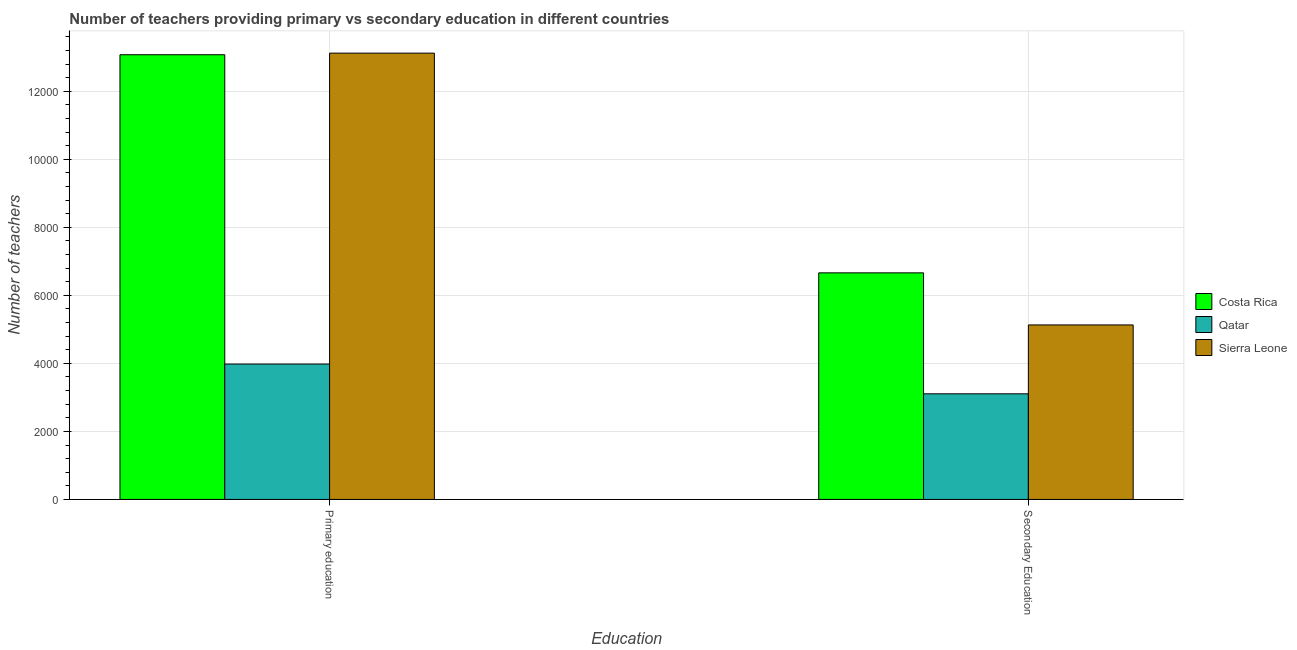How many groups of bars are there?
Offer a very short reply. 2. Are the number of bars per tick equal to the number of legend labels?
Your answer should be compact. Yes. Are the number of bars on each tick of the X-axis equal?
Your answer should be very brief. Yes. How many bars are there on the 2nd tick from the left?
Offer a very short reply. 3. What is the number of primary teachers in Costa Rica?
Keep it short and to the point. 1.31e+04. Across all countries, what is the maximum number of secondary teachers?
Keep it short and to the point. 6661. Across all countries, what is the minimum number of secondary teachers?
Provide a succinct answer. 3105. In which country was the number of primary teachers maximum?
Provide a succinct answer. Sierra Leone. In which country was the number of primary teachers minimum?
Provide a short and direct response. Qatar. What is the total number of primary teachers in the graph?
Provide a succinct answer. 3.02e+04. What is the difference between the number of primary teachers in Costa Rica and that in Qatar?
Offer a terse response. 9093. What is the difference between the number of secondary teachers in Sierra Leone and the number of primary teachers in Costa Rica?
Provide a succinct answer. -7943. What is the average number of secondary teachers per country?
Provide a short and direct response. 4965.33. What is the difference between the number of secondary teachers and number of primary teachers in Sierra Leone?
Keep it short and to the point. -7990. What is the ratio of the number of secondary teachers in Costa Rica to that in Sierra Leone?
Your answer should be compact. 1.3. Is the number of primary teachers in Sierra Leone less than that in Qatar?
Your answer should be very brief. No. What does the 2nd bar from the left in Primary education represents?
Keep it short and to the point. Qatar. What does the 3rd bar from the right in Secondary Education represents?
Your response must be concise. Costa Rica. Are all the bars in the graph horizontal?
Provide a short and direct response. No. How many countries are there in the graph?
Offer a very short reply. 3. What is the difference between two consecutive major ticks on the Y-axis?
Your response must be concise. 2000. Does the graph contain grids?
Ensure brevity in your answer.  Yes. How are the legend labels stacked?
Your response must be concise. Vertical. What is the title of the graph?
Your response must be concise. Number of teachers providing primary vs secondary education in different countries. What is the label or title of the X-axis?
Offer a terse response. Education. What is the label or title of the Y-axis?
Keep it short and to the point. Number of teachers. What is the Number of teachers of Costa Rica in Primary education?
Your answer should be compact. 1.31e+04. What is the Number of teachers in Qatar in Primary education?
Provide a succinct answer. 3980. What is the Number of teachers of Sierra Leone in Primary education?
Keep it short and to the point. 1.31e+04. What is the Number of teachers in Costa Rica in Secondary Education?
Offer a terse response. 6661. What is the Number of teachers of Qatar in Secondary Education?
Ensure brevity in your answer.  3105. What is the Number of teachers of Sierra Leone in Secondary Education?
Your answer should be compact. 5130. Across all Education, what is the maximum Number of teachers of Costa Rica?
Your answer should be very brief. 1.31e+04. Across all Education, what is the maximum Number of teachers of Qatar?
Your response must be concise. 3980. Across all Education, what is the maximum Number of teachers in Sierra Leone?
Keep it short and to the point. 1.31e+04. Across all Education, what is the minimum Number of teachers in Costa Rica?
Offer a terse response. 6661. Across all Education, what is the minimum Number of teachers in Qatar?
Ensure brevity in your answer.  3105. Across all Education, what is the minimum Number of teachers of Sierra Leone?
Keep it short and to the point. 5130. What is the total Number of teachers of Costa Rica in the graph?
Offer a very short reply. 1.97e+04. What is the total Number of teachers of Qatar in the graph?
Make the answer very short. 7085. What is the total Number of teachers in Sierra Leone in the graph?
Provide a short and direct response. 1.82e+04. What is the difference between the Number of teachers in Costa Rica in Primary education and that in Secondary Education?
Offer a very short reply. 6412. What is the difference between the Number of teachers in Qatar in Primary education and that in Secondary Education?
Ensure brevity in your answer.  875. What is the difference between the Number of teachers in Sierra Leone in Primary education and that in Secondary Education?
Ensure brevity in your answer.  7990. What is the difference between the Number of teachers of Costa Rica in Primary education and the Number of teachers of Qatar in Secondary Education?
Give a very brief answer. 9968. What is the difference between the Number of teachers of Costa Rica in Primary education and the Number of teachers of Sierra Leone in Secondary Education?
Offer a terse response. 7943. What is the difference between the Number of teachers in Qatar in Primary education and the Number of teachers in Sierra Leone in Secondary Education?
Offer a terse response. -1150. What is the average Number of teachers in Costa Rica per Education?
Provide a succinct answer. 9867. What is the average Number of teachers of Qatar per Education?
Provide a short and direct response. 3542.5. What is the average Number of teachers of Sierra Leone per Education?
Your response must be concise. 9125. What is the difference between the Number of teachers in Costa Rica and Number of teachers in Qatar in Primary education?
Offer a very short reply. 9093. What is the difference between the Number of teachers of Costa Rica and Number of teachers of Sierra Leone in Primary education?
Offer a very short reply. -47. What is the difference between the Number of teachers of Qatar and Number of teachers of Sierra Leone in Primary education?
Keep it short and to the point. -9140. What is the difference between the Number of teachers in Costa Rica and Number of teachers in Qatar in Secondary Education?
Provide a succinct answer. 3556. What is the difference between the Number of teachers of Costa Rica and Number of teachers of Sierra Leone in Secondary Education?
Offer a very short reply. 1531. What is the difference between the Number of teachers in Qatar and Number of teachers in Sierra Leone in Secondary Education?
Offer a very short reply. -2025. What is the ratio of the Number of teachers of Costa Rica in Primary education to that in Secondary Education?
Provide a short and direct response. 1.96. What is the ratio of the Number of teachers of Qatar in Primary education to that in Secondary Education?
Provide a succinct answer. 1.28. What is the ratio of the Number of teachers in Sierra Leone in Primary education to that in Secondary Education?
Your response must be concise. 2.56. What is the difference between the highest and the second highest Number of teachers of Costa Rica?
Your response must be concise. 6412. What is the difference between the highest and the second highest Number of teachers of Qatar?
Ensure brevity in your answer.  875. What is the difference between the highest and the second highest Number of teachers in Sierra Leone?
Keep it short and to the point. 7990. What is the difference between the highest and the lowest Number of teachers in Costa Rica?
Provide a succinct answer. 6412. What is the difference between the highest and the lowest Number of teachers of Qatar?
Your answer should be very brief. 875. What is the difference between the highest and the lowest Number of teachers of Sierra Leone?
Ensure brevity in your answer.  7990. 